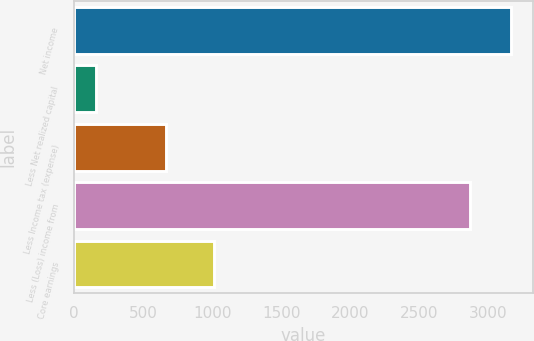<chart> <loc_0><loc_0><loc_500><loc_500><bar_chart><fcel>Net income<fcel>Less Net realized capital<fcel>Less Income tax (expense)<fcel>Less (Loss) income from<fcel>Core earnings<nl><fcel>3166.1<fcel>160<fcel>669<fcel>2869<fcel>1014<nl></chart> 